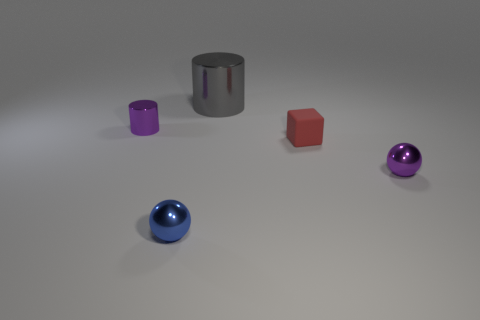Are there the same number of cubes that are to the left of the large shiny cylinder and small cyan cylinders?
Make the answer very short. Yes. Is there anything else that is made of the same material as the red object?
Make the answer very short. No. There is a rubber thing; does it have the same color as the cylinder on the right side of the tiny purple metallic cylinder?
Your response must be concise. No. Is there a tiny blue thing behind the thing in front of the object to the right of the small red matte block?
Offer a very short reply. No. Is the number of matte objects left of the blue metal sphere less than the number of red matte cubes?
Your response must be concise. Yes. What number of other objects are there of the same shape as the large object?
Keep it short and to the point. 1. What number of objects are either tiny things to the right of the matte thing or shiny things that are behind the red thing?
Your response must be concise. 3. What size is the thing that is in front of the small red thing and right of the big thing?
Offer a very short reply. Small. There is a tiny purple metallic object that is left of the gray shiny cylinder; is it the same shape as the gray thing?
Provide a succinct answer. Yes. How big is the purple thing on the left side of the tiny sphere that is behind the shiny ball that is left of the big gray cylinder?
Provide a succinct answer. Small. 